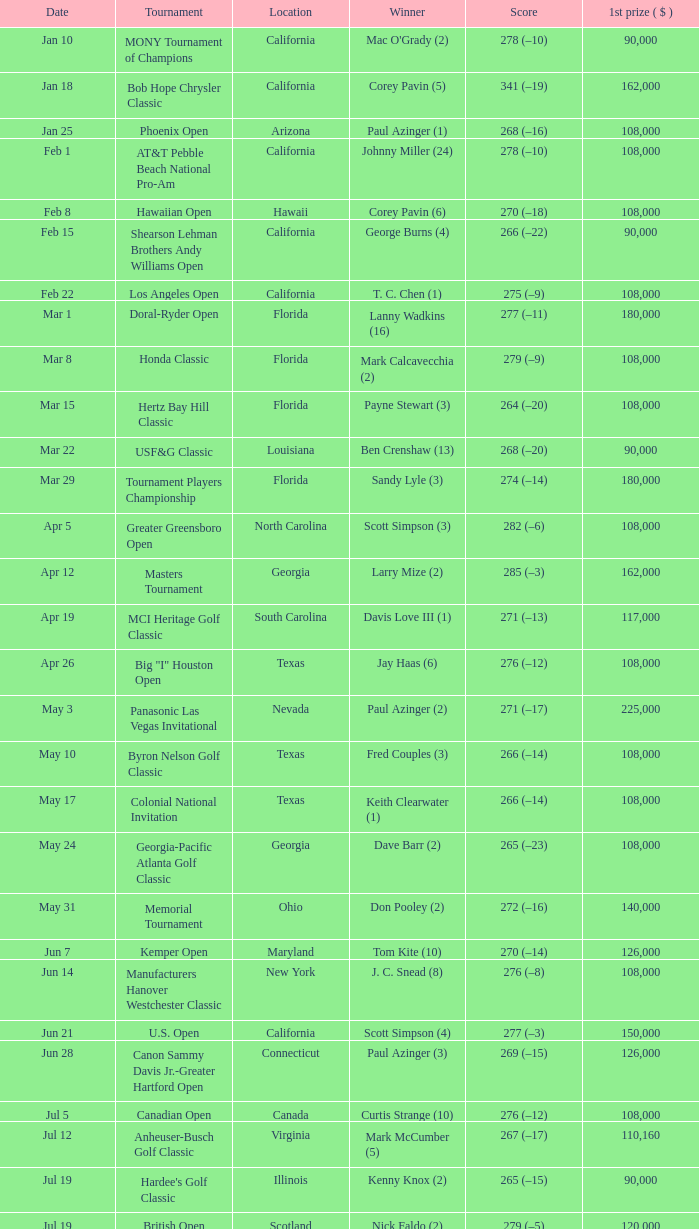What was the victorious score of keith clearwater (1)? 266 (–14). 